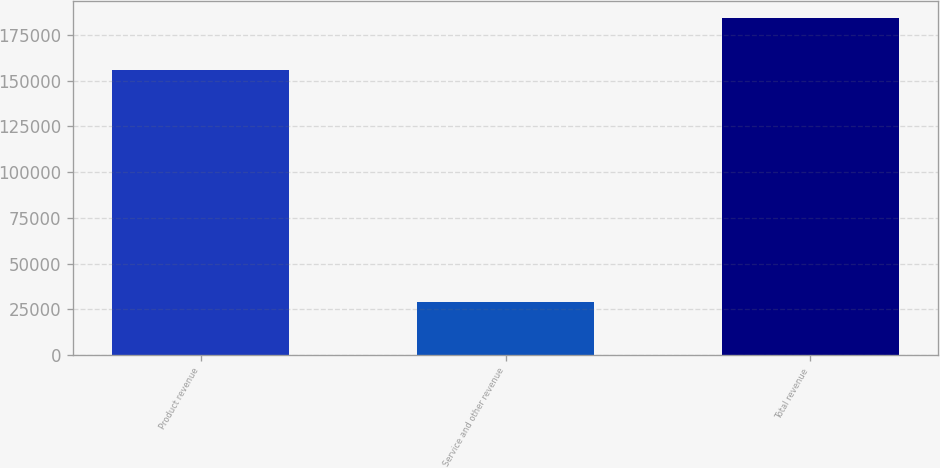Convert chart. <chart><loc_0><loc_0><loc_500><loc_500><bar_chart><fcel>Product revenue<fcel>Service and other revenue<fcel>Total revenue<nl><fcel>155811<fcel>28775<fcel>184586<nl></chart> 